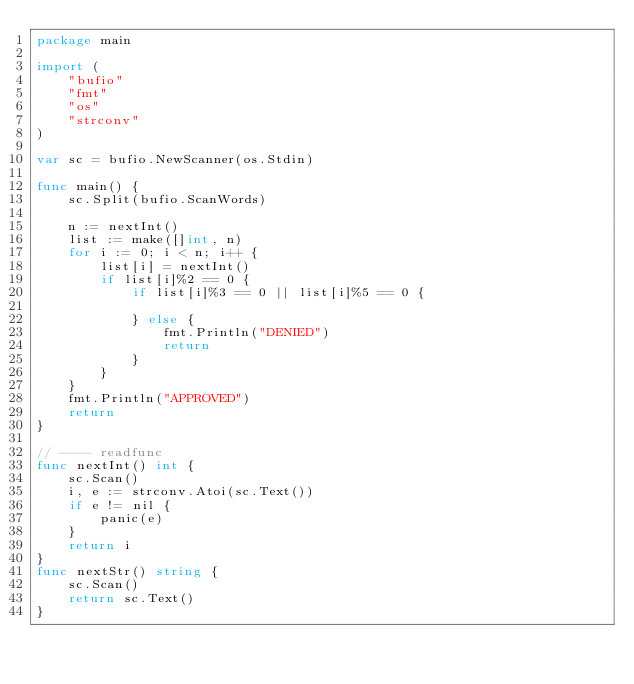<code> <loc_0><loc_0><loc_500><loc_500><_Go_>package main

import (
	"bufio"
	"fmt"
	"os"
	"strconv"
)

var sc = bufio.NewScanner(os.Stdin)

func main() {
	sc.Split(bufio.ScanWords)

	n := nextInt()
	list := make([]int, n)
	for i := 0; i < n; i++ {
		list[i] = nextInt()
		if list[i]%2 == 0 {
			if list[i]%3 == 0 || list[i]%5 == 0 {

			} else {
				fmt.Println("DENIED")
				return
			}
		}
	}
	fmt.Println("APPROVED")
	return
}

// ---- readfunc
func nextInt() int {
	sc.Scan()
	i, e := strconv.Atoi(sc.Text())
	if e != nil {
		panic(e)
	}
	return i
}
func nextStr() string {
	sc.Scan()
	return sc.Text()
}
</code> 